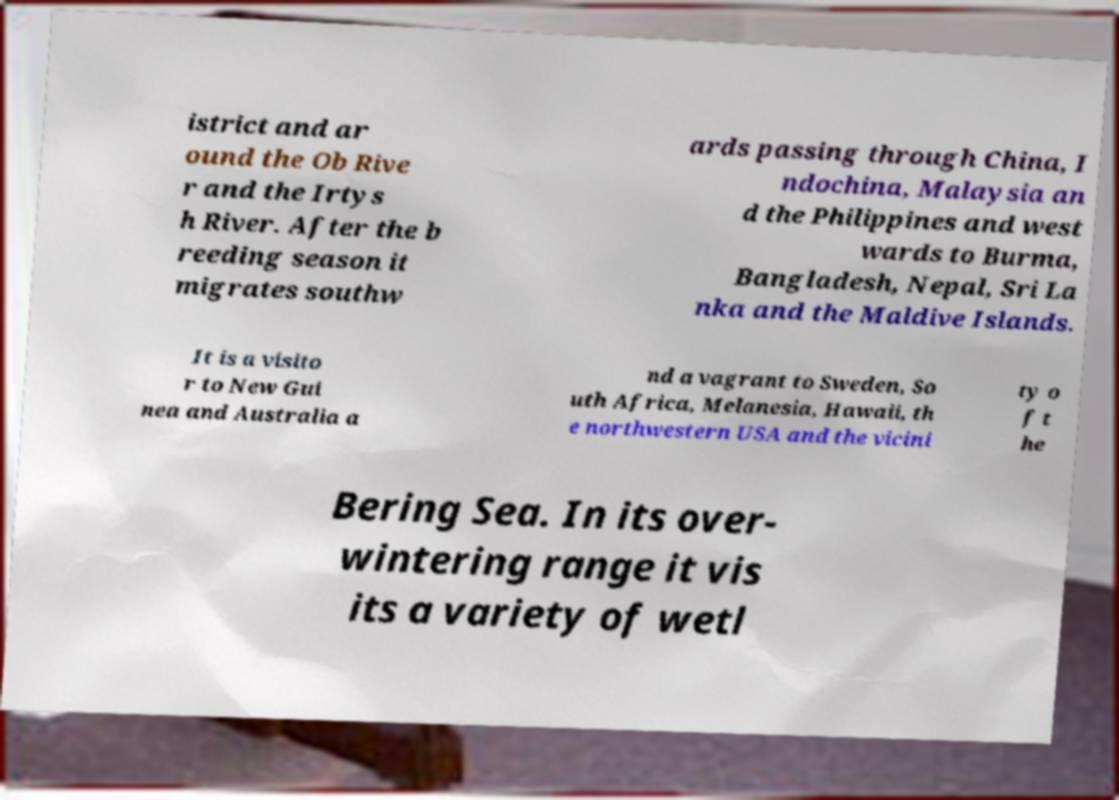There's text embedded in this image that I need extracted. Can you transcribe it verbatim? istrict and ar ound the Ob Rive r and the Irtys h River. After the b reeding season it migrates southw ards passing through China, I ndochina, Malaysia an d the Philippines and west wards to Burma, Bangladesh, Nepal, Sri La nka and the Maldive Islands. It is a visito r to New Gui nea and Australia a nd a vagrant to Sweden, So uth Africa, Melanesia, Hawaii, th e northwestern USA and the vicini ty o f t he Bering Sea. In its over- wintering range it vis its a variety of wetl 